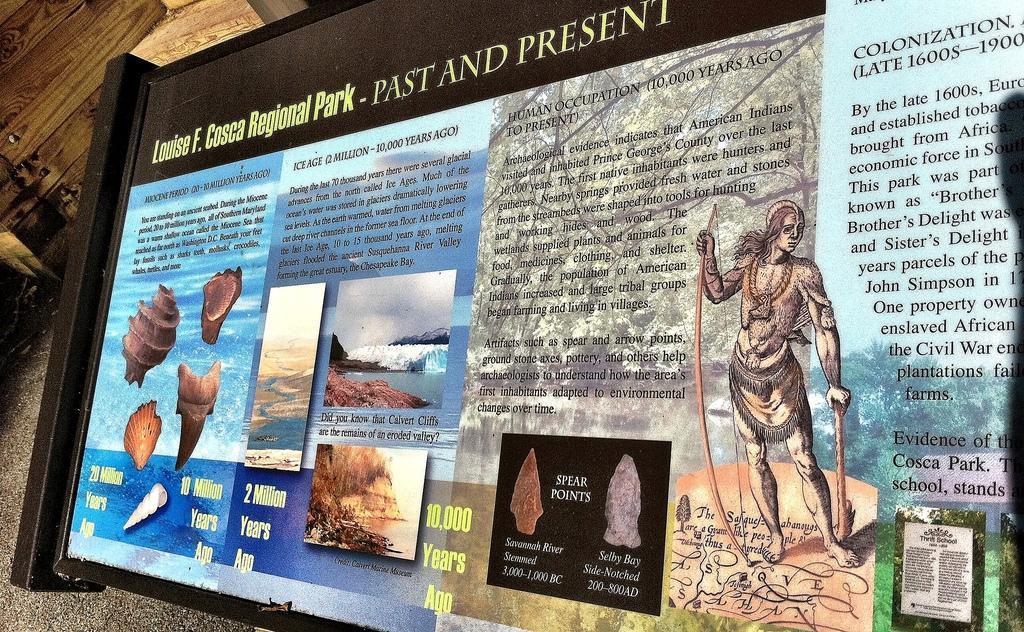In one or two sentences, can you explain what this image depicts? In this image there is a board on the wall in which we can see there is some text and photos. 